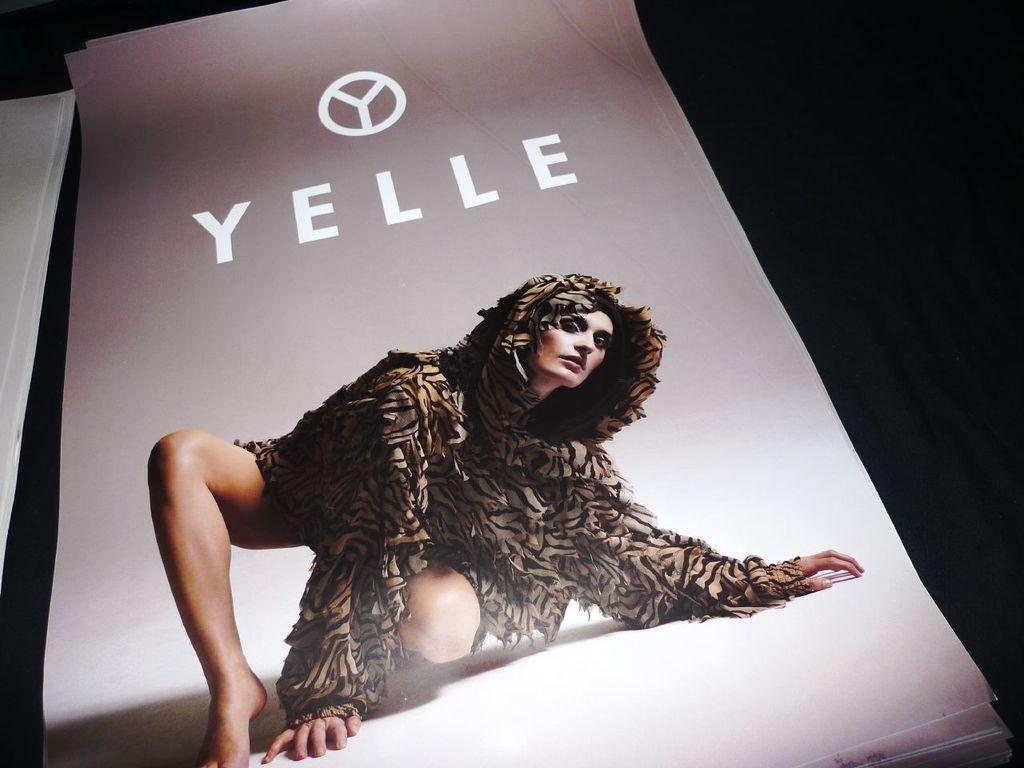Who or what is present in the image? There is a person in the image. What can be seen on the person or near them? There is a logo in the image. What is written on a paper in the image? There is a word on a paper in the image. How many papers are visible in the image? There are papers in the image. What is the color of the background in the image? The background of the image is dark. How many apples are on the person's head in the image? There are no apples present in the image. Is the person wearing a crown in the image? There is no crown visible in the image. 